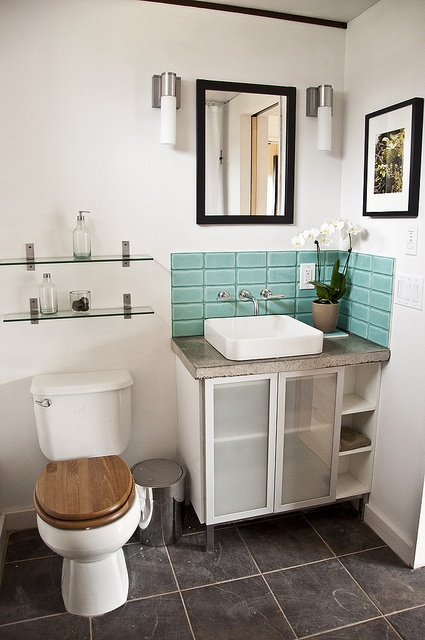Describe the objects in this image and their specific colors. I can see toilet in gray, lightgray, and darkgray tones, sink in gray, lightgray, and darkgray tones, potted plant in gray, lightgray, black, and teal tones, bottle in gray, lightgray, and darkgray tones, and bottle in gray, darkgray, and lightgray tones in this image. 